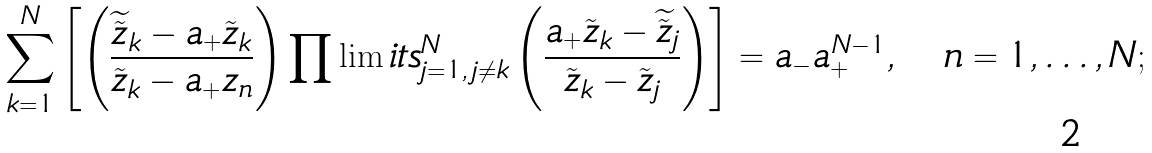<formula> <loc_0><loc_0><loc_500><loc_500>\sum _ { k = 1 } ^ { N } \left [ \left ( \frac { \widetilde { \tilde { z } } _ { k } - a _ { + } \tilde { z } _ { k } } { \tilde { z } _ { k } - a _ { + } z _ { n } } \right ) \prod \lim i t s _ { j = 1 , \, j \neq k } ^ { N } \left ( \frac { a _ { + } \tilde { z } _ { k } - \widetilde { \tilde { z } } _ { j } } { \tilde { z } _ { k } - \tilde { z } _ { j } } \right ) \right ] = a _ { - } a _ { + } ^ { N - 1 } , \quad n = 1 , \dots , N ;</formula> 